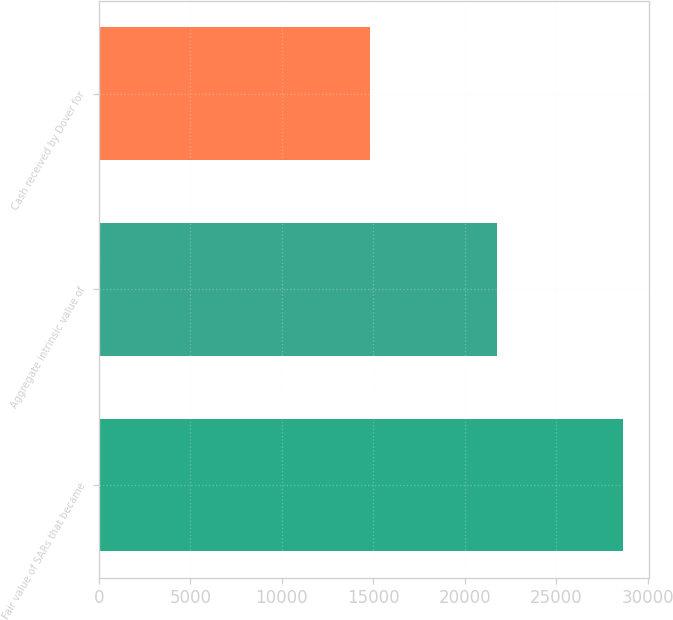<chart> <loc_0><loc_0><loc_500><loc_500><bar_chart><fcel>Fair value of SARs that became<fcel>Aggregate intrinsic value of<fcel>Cash received by Dover for<nl><fcel>28652.8<fcel>21741.4<fcel>14830<nl></chart> 